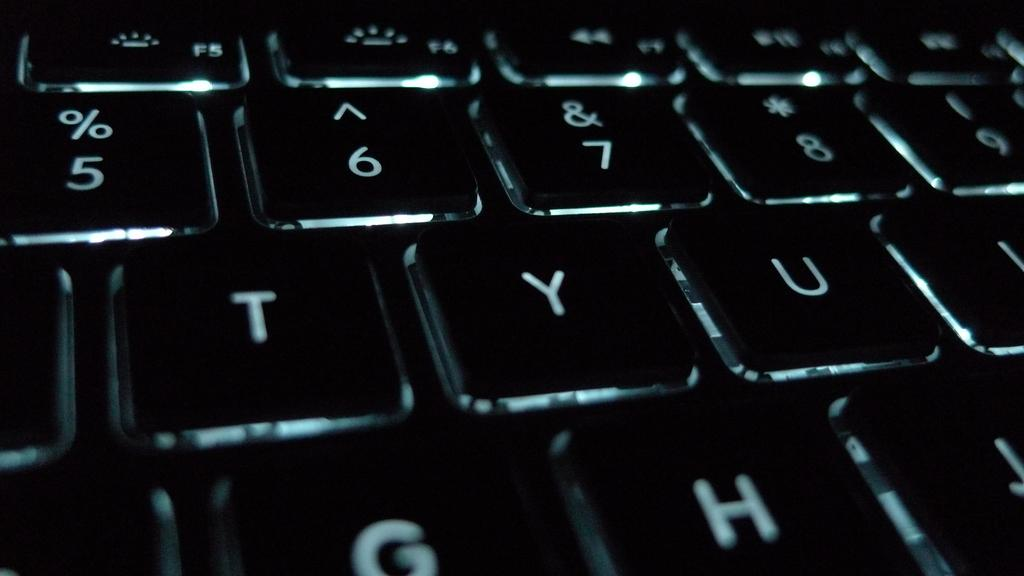<image>
Create a compact narrative representing the image presented. A black keyoboard with buttons such as TYU and some numbers. 